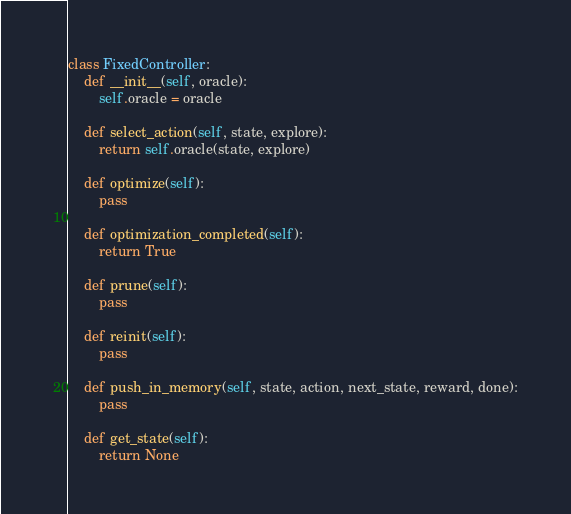Convert code to text. <code><loc_0><loc_0><loc_500><loc_500><_Python_>class FixedController:
    def __init__(self, oracle):
        self.oracle = oracle

    def select_action(self, state, explore):
        return self.oracle(state, explore)

    def optimize(self):
        pass

    def optimization_completed(self):
        return True

    def prune(self):
        pass

    def reinit(self):
        pass

    def push_in_memory(self, state, action, next_state, reward, done):
        pass

    def get_state(self):
        return None
</code> 